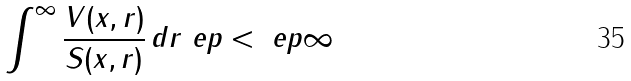Convert formula to latex. <formula><loc_0><loc_0><loc_500><loc_500>\int ^ { \infty } \frac { V ( x , r ) } { S ( x , r ) } \, d r \ e p < \ e p \infty</formula> 